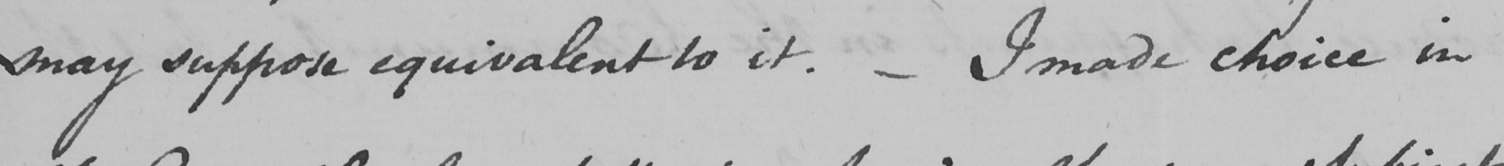What text is written in this handwritten line? may suppose equivalent to it .  _  I made choice in 